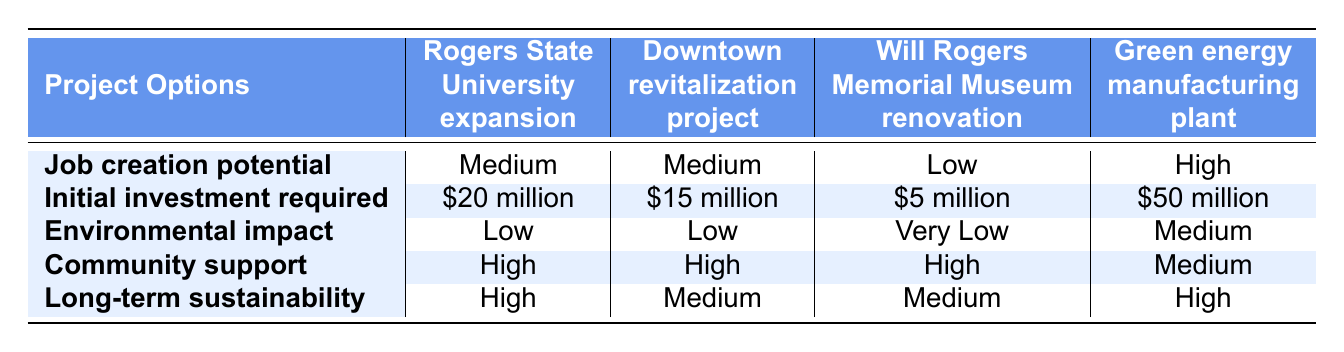What is the job creation potential of the Downtown revitalization project? The table states that the job creation potential for the Downtown revitalization project is "Medium."
Answer: Medium How much initial investment is required for the Green energy manufacturing plant? According to the table, the required initial investment for the Green energy manufacturing plant is "$50 million."
Answer: $50 million Is there high community support for the Will Rogers Memorial Museum renovation? The table indicates that the community support for the Will Rogers Memorial Museum renovation is "High." Therefore, the answer is yes, there is high community support.
Answer: Yes Which project option has the highest long-term sustainability? From the table, both the Rogers State University expansion and the Green energy manufacturing plant have "High" long-term sustainability. Thus, the options with the highest sustainability are these two.
Answer: Rogers State University expansion and Green energy manufacturing plant If we look only at projects with high community support, which option requires the least initial investment? The projects with high community support are the Rogers State University expansion, Downtown revitalization project, and Will Rogers Memorial Museum renovation. Their initial investments are $20 million, $15 million, and $5 million, respectively. The least investment among these is $5 million for the Will Rogers Memorial Museum renovation.
Answer: Will Rogers Memorial Museum renovation What is the environmental impact rating of the Downtown revitalization project? The table shows that the environmental impact of the Downtown revitalization project is "Low."
Answer: Low Which project has the lowest job creation potential and what is it? According to the table, the project with the lowest job creation potential is the Will Rogers Memorial Museum renovation, which has a rating of "Low."
Answer: Will Rogers Memorial Museum renovation How do the job creation potentials compare between Rogers State University expansion and Green energy manufacturing plant? The Rogers State University expansion has a job creation potential of "Medium," while the Green energy manufacturing plant has "High." Medium is lower than High, indicating that the Green energy manufacturing plant has a better job creation potential.
Answer: Green energy manufacturing plant Is the environmental impact for any project classified as "Very Low"? Yes, the table shows that the Will Rogers Memorial Museum renovation has an environmental impact classified as "Very Low."
Answer: Yes 